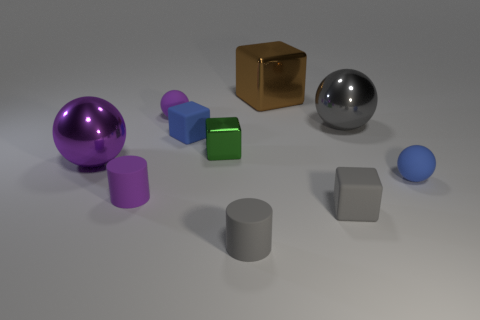Is there a small metallic sphere of the same color as the small metallic object?
Your answer should be compact. No. There is a large metal object that is in front of the purple matte ball and behind the green shiny cube; what is its shape?
Your response must be concise. Sphere. What number of small blue things are the same material as the tiny blue cube?
Your answer should be very brief. 1. Are there fewer gray rubber blocks behind the blue sphere than purple shiny spheres to the left of the purple matte cylinder?
Give a very brief answer. Yes. The big cube that is behind the rubber cube in front of the tiny object that is on the right side of the tiny gray block is made of what material?
Keep it short and to the point. Metal. There is a gray thing that is right of the big brown cube and in front of the blue ball; how big is it?
Give a very brief answer. Small. What number of balls are either large purple shiny things or blue things?
Provide a succinct answer. 2. What is the color of the other matte cylinder that is the same size as the gray rubber cylinder?
Provide a succinct answer. Purple. Is there any other thing that is the same shape as the large purple object?
Give a very brief answer. Yes. There is another shiny object that is the same shape as the purple shiny thing; what is its color?
Make the answer very short. Gray. 